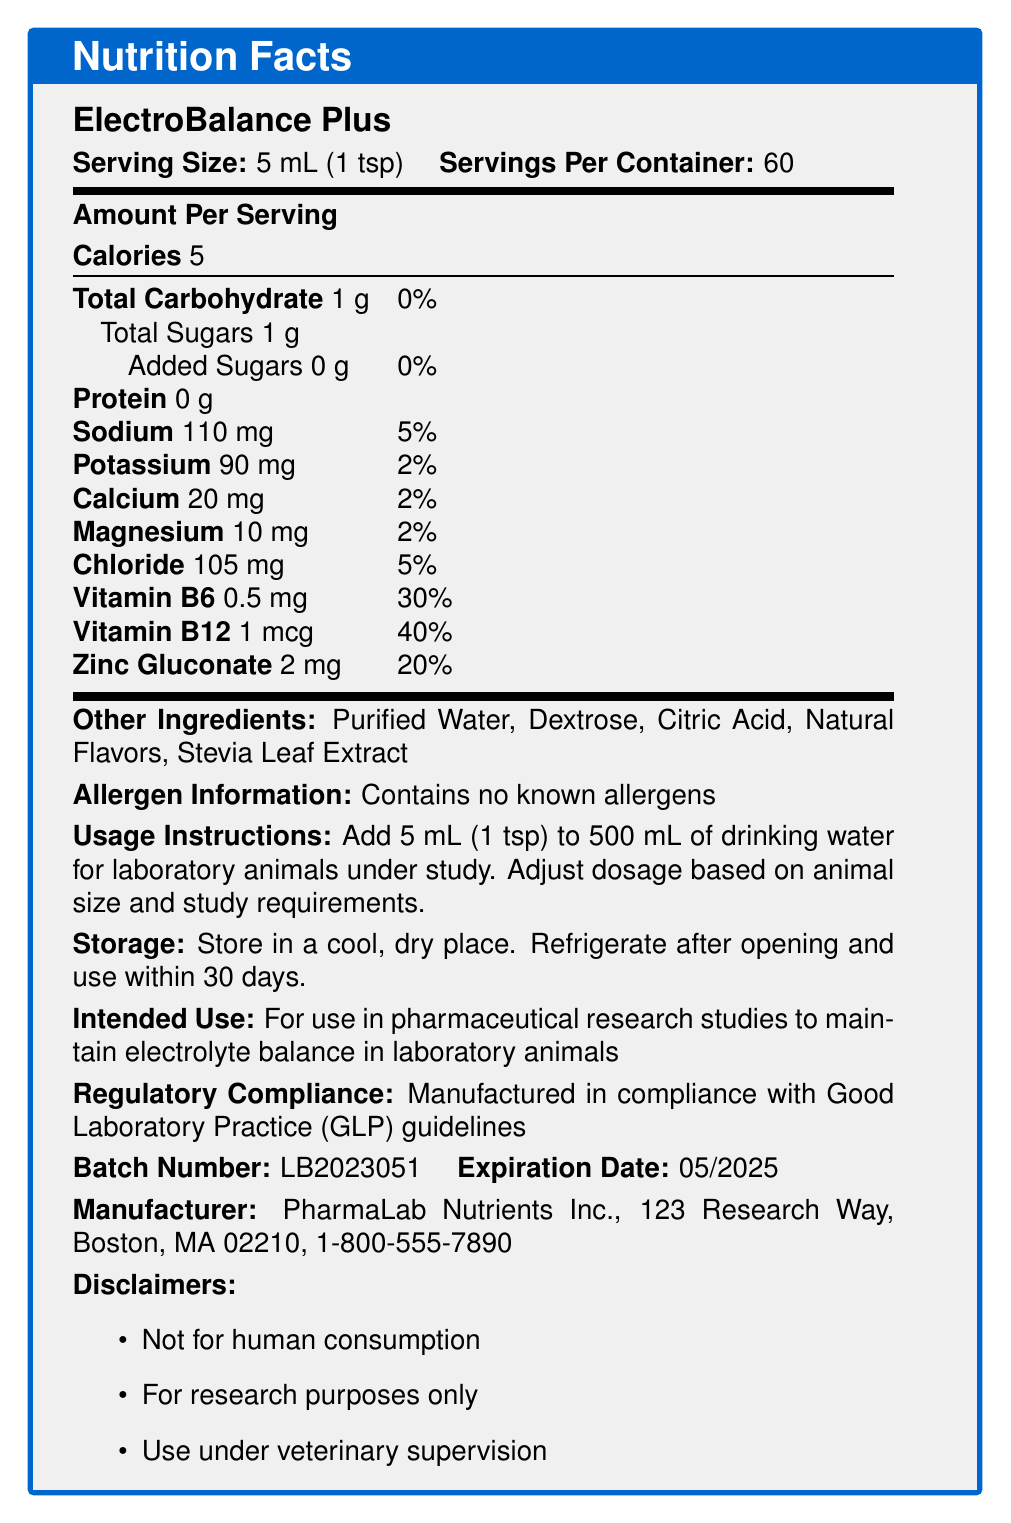what is the serving size for ElectroBalance Plus? The serving size is explicitly mentioned as "5 mL (1 tsp)" in the document.
Answer: 5 mL (1 tsp) how many calories are there per serving of ElectroBalance Plus? The document states that there are 5 calories per serving.
Answer: 5 calories what percentage of the daily value of sodium does one serving of ElectroBalance Plus provide? The document lists sodium as providing 5% of the daily value per serving.
Answer: 5% how much Vitamin B12 is in one serving of ElectroBalance Plus? The document specifies that one serving contains 1 mcg of Vitamin B12.
Answer: 1 mcg what are the main ingredients of ElectroBalance Plus, excluding the additional nutrients? The document lists these as the "Other Ingredients."
Answer: Purified Water, Dextrose, Citric Acid, Natural Flavors, Stevia Leaf Extract which nutrient has the highest daily value percentage in ElectroBalance Plus? A. Vitamin B6 B. Sodium C. Zinc Gluconate D. Vitamin B12 Vitamin B12 has a daily value of 40%, which is the highest among the nutrients listed.
Answer: D. Vitamin B12 how much potassium is in one serving of ElectroBalance Plus? A. 20 mg B. 90 mg C. 110 mg D. 105 mg The document states that one serving contains 90 mg of potassium.
Answer: B. 90 mg is there any protein in ElectroBalance Plus? The document lists protein as "0 g," indicating that there is no protein.
Answer: No is ElectroBalance Plus safe for human consumption? The disclaimers specifically state, "Not for human consumption."
Answer: No summarize the main purpose and details of the ElectroBalance Plus document. The document gives comprehensive information on ElectroBalance Plus, listing its nutritional content, proper use, and compliance with regulations to guide researchers in maintaining the health of laboratory animals.
Answer: The document provides the Nutrition Facts for ElectroBalance Plus, a nutrient-enriched water additive designed to maintain electrolyte balance in laboratory animals. The document includes serving size, nutrient amounts and daily values, other ingredients, allergen information, usage and storage instructions, intended use, regulatory compliance, batch and expiration details, manufacturer information, and disclaimers. what is the expiration date of ElectroBalance Plus? The document specifies the expiration date as "05/2025."
Answer: 05/2025 how many servings are there in one container of ElectroBalance Plus? The document states that there are 60 servings per container.
Answer: 60 servings where is PharmaLab Nutrients Inc. located? The document provides the manufacturer's address as "123 Research Way, Boston, MA 02210."
Answer: 123 Research Way, Boston, MA 02210 what is the dosage recommendation for animals based on size? The document mentions adjusting the dosage based on animal size and study requirements but does not provide specific recommendations.
Answer: Not enough information what is the regulatory compliance for ElectroBalance Plus? The document states that the product is manufactured in compliance with Good Laboratory Practice (GLP) guidelines.
Answer: Good Laboratory Practice (GLP) guidelines how should ElectroBalance Plus be stored after opening? The document advises to refrigerate the product after opening and use it within 30 days.
Answer: Refrigerate after opening and use within 30 days 